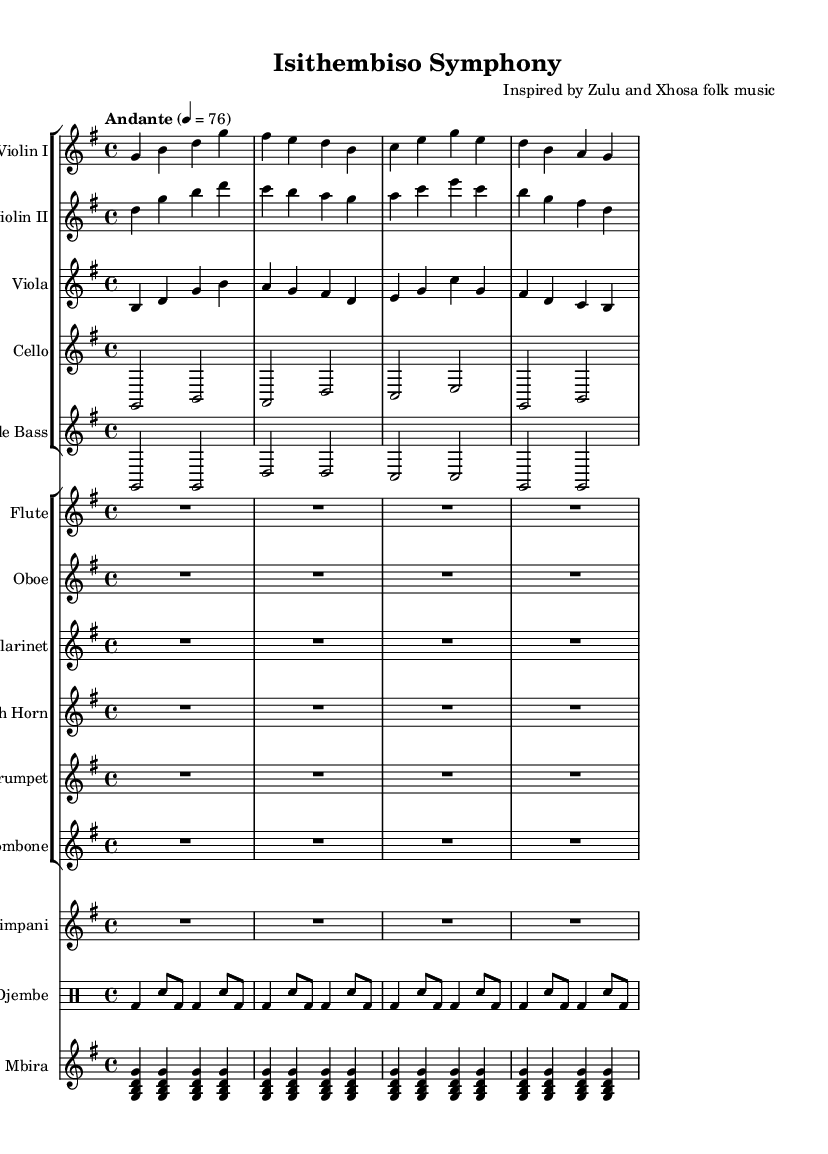What is the key signature of this music? The key signature is determined by looking at the initial part of the score where it indicates one sharp. This leads us to the conclusion that the key is G major.
Answer: G major What is the time signature of this music? The time signature is found next to the key signature at the beginning of the score, showing 4 over 4, which indicates a common time.
Answer: 4/4 What is the tempo marking of this symphony? The tempo marking appears at the start of the score, stating "Andante" with a metronome marking of 76 beats per minute. This specifies the pace of the performance.
Answer: Andante 4 = 76 How many measures does the djembe part have? To find this, we count the groups of notes in the djembe section, where each group or line represents one measure. The score shows four measures repeated, making it a total of four.
Answer: 4 Which instrument plays the role of sustained harmony in this symphony? By examining the instruments listed, one can identify that the cello generally plays sustained harmonies, often providing the bass line and harmonic support in symphonic music.
Answer: Cello What type of music influences are present in this symphony? The influences are indicated in the header of the score and suggest inspiration from Zulu and Xhosa folk music, showcasing the integration of these rich musical traditions into a classical format.
Answer: Zulu and Xhosa folk music How does the mbira contribute to the texture of the symphony? The mbira part is seen playing chord clusters repeatedly, which adds a unique texture and rhythmic element to the symphony, integrating traditional sounds that enrich the overall musical experience.
Answer: Unique texture 